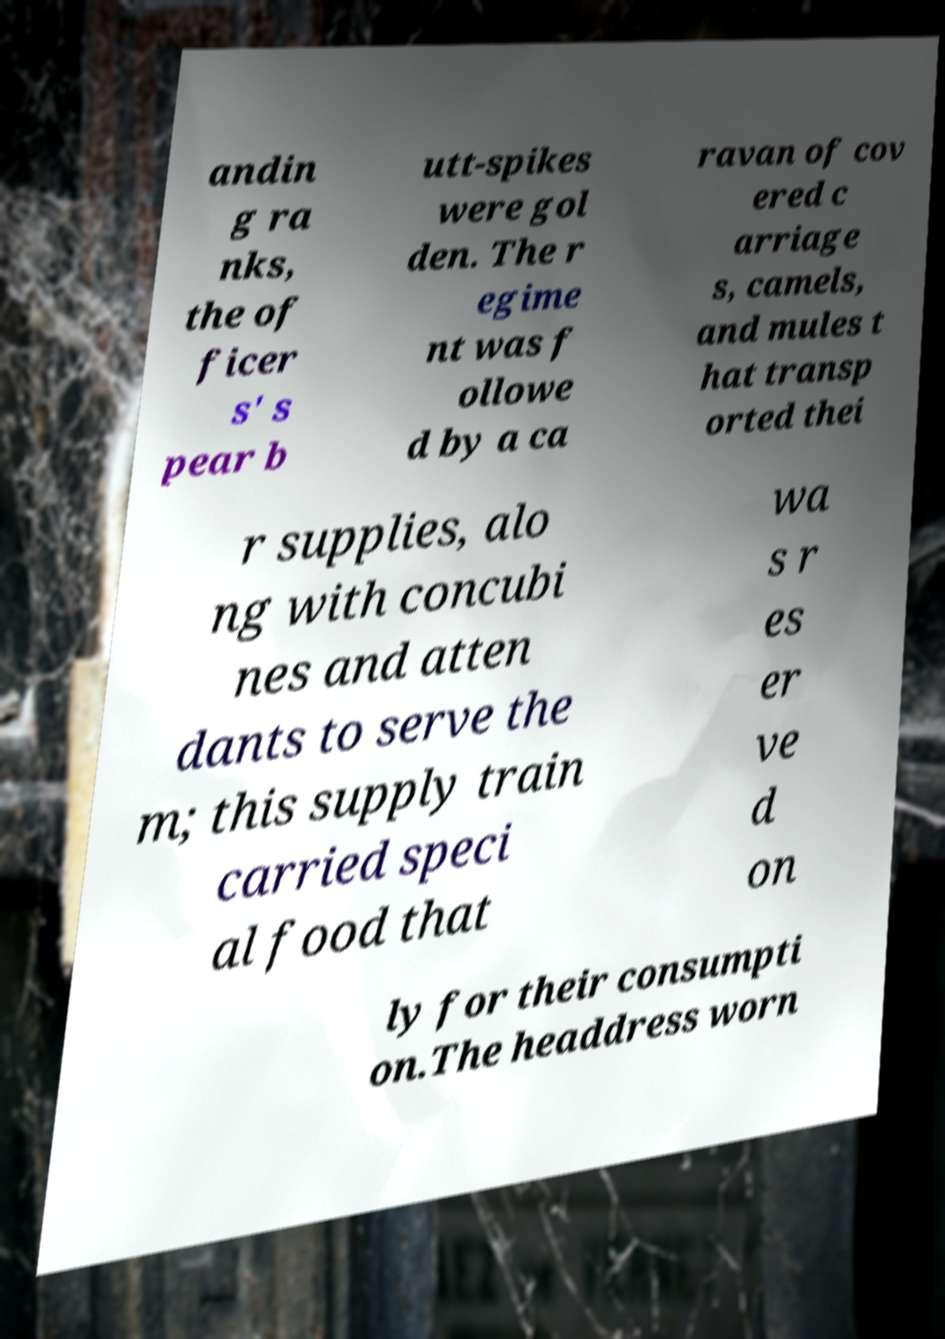Please read and relay the text visible in this image. What does it say? andin g ra nks, the of ficer s' s pear b utt-spikes were gol den. The r egime nt was f ollowe d by a ca ravan of cov ered c arriage s, camels, and mules t hat transp orted thei r supplies, alo ng with concubi nes and atten dants to serve the m; this supply train carried speci al food that wa s r es er ve d on ly for their consumpti on.The headdress worn 